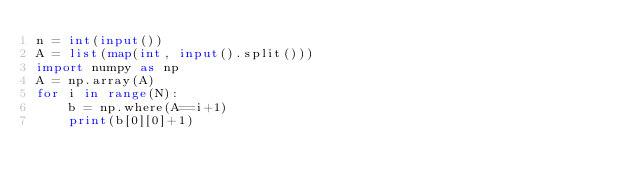Convert code to text. <code><loc_0><loc_0><loc_500><loc_500><_Python_>n = int(input())
A = list(map(int, input().split()))
import numpy as np
A = np.array(A)
for i in range(N):
    b = np.where(A==i+1)
    print(b[0][0]+1)</code> 